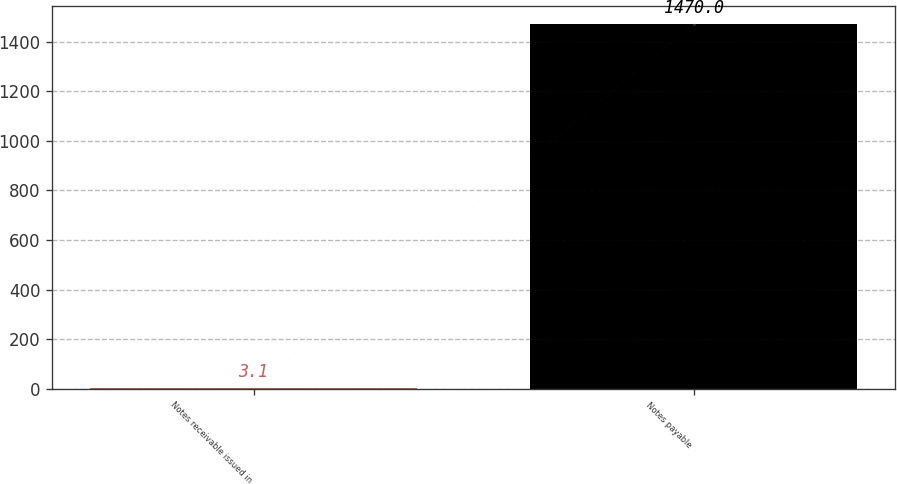Convert chart to OTSL. <chart><loc_0><loc_0><loc_500><loc_500><bar_chart><fcel>Notes receivable issued in<fcel>Notes payable<nl><fcel>3.1<fcel>1470<nl></chart> 